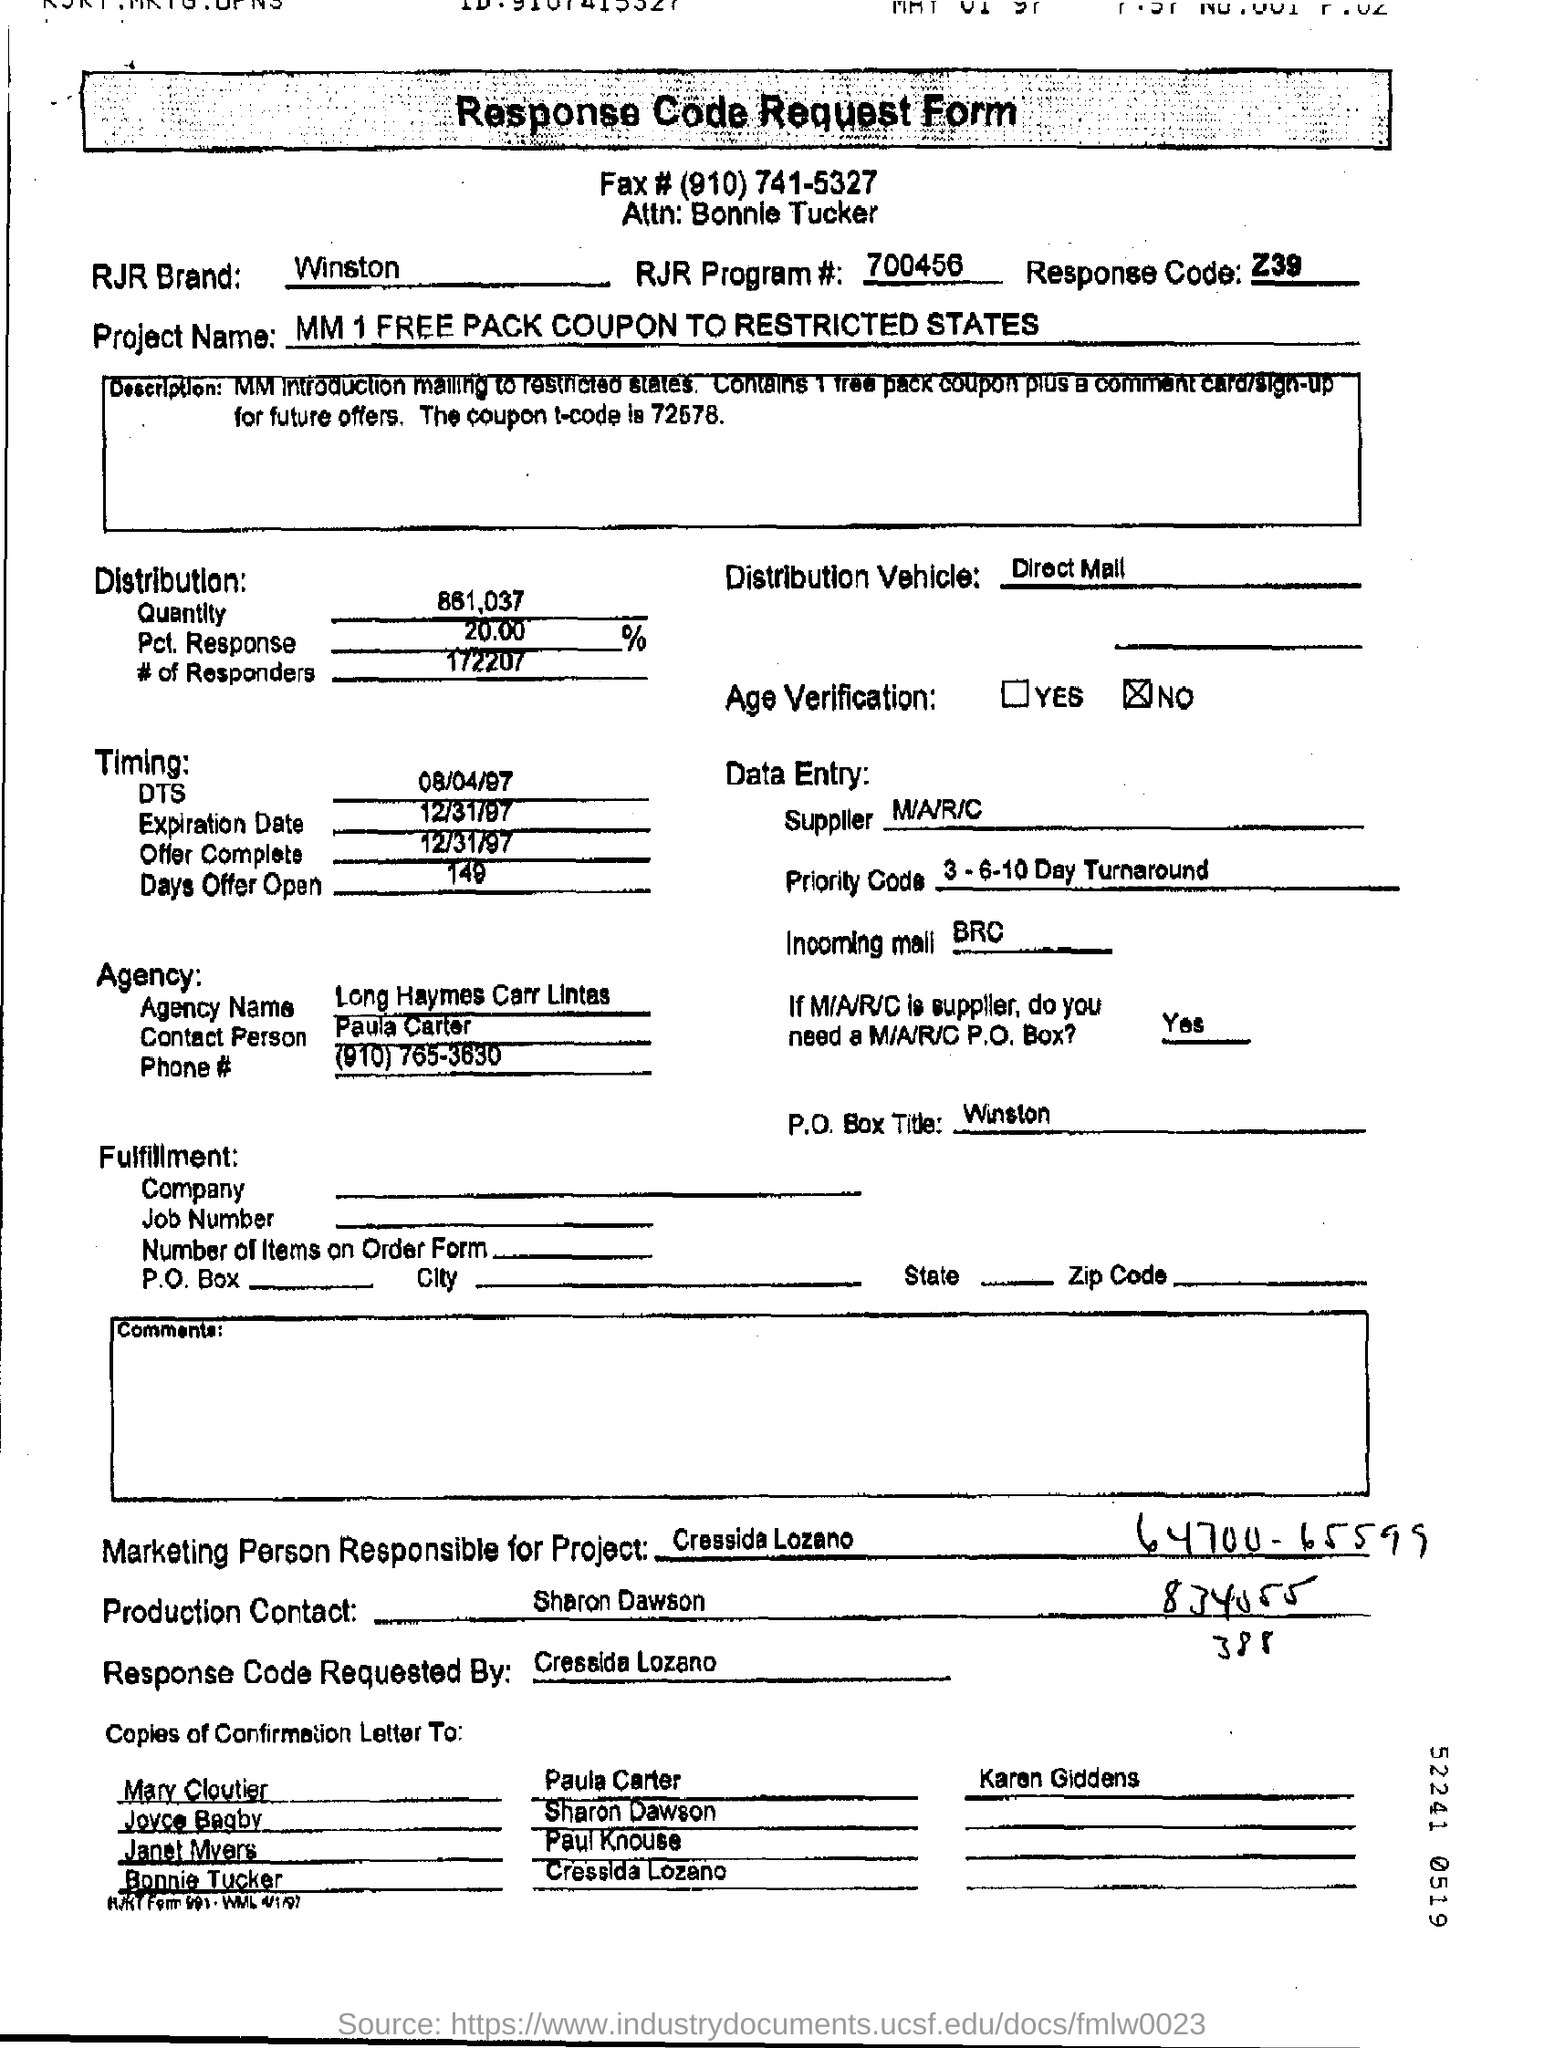List a handful of essential elements in this visual. The RJR Brand is a company that produces cigarettes, including the Winston brand. What is the RJR brand? It is Winston. The supplier is M/A/R/C. There is no age verification. 